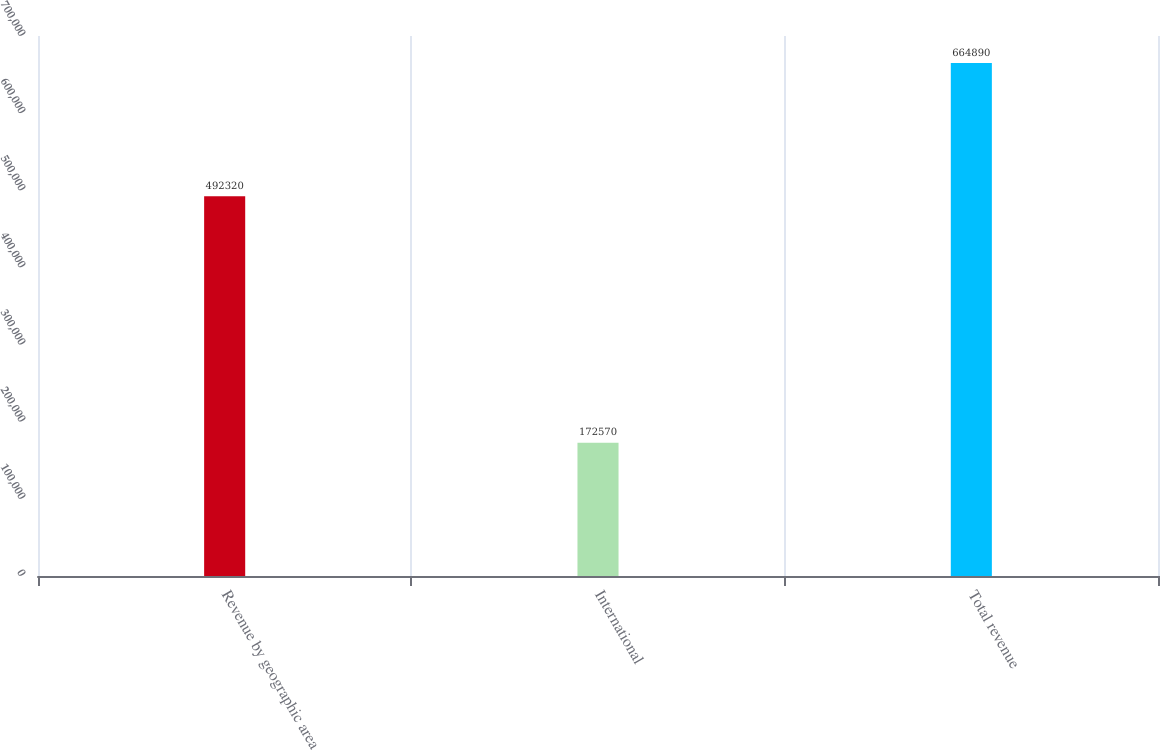<chart> <loc_0><loc_0><loc_500><loc_500><bar_chart><fcel>Revenue by geographic area<fcel>International<fcel>Total revenue<nl><fcel>492320<fcel>172570<fcel>664890<nl></chart> 